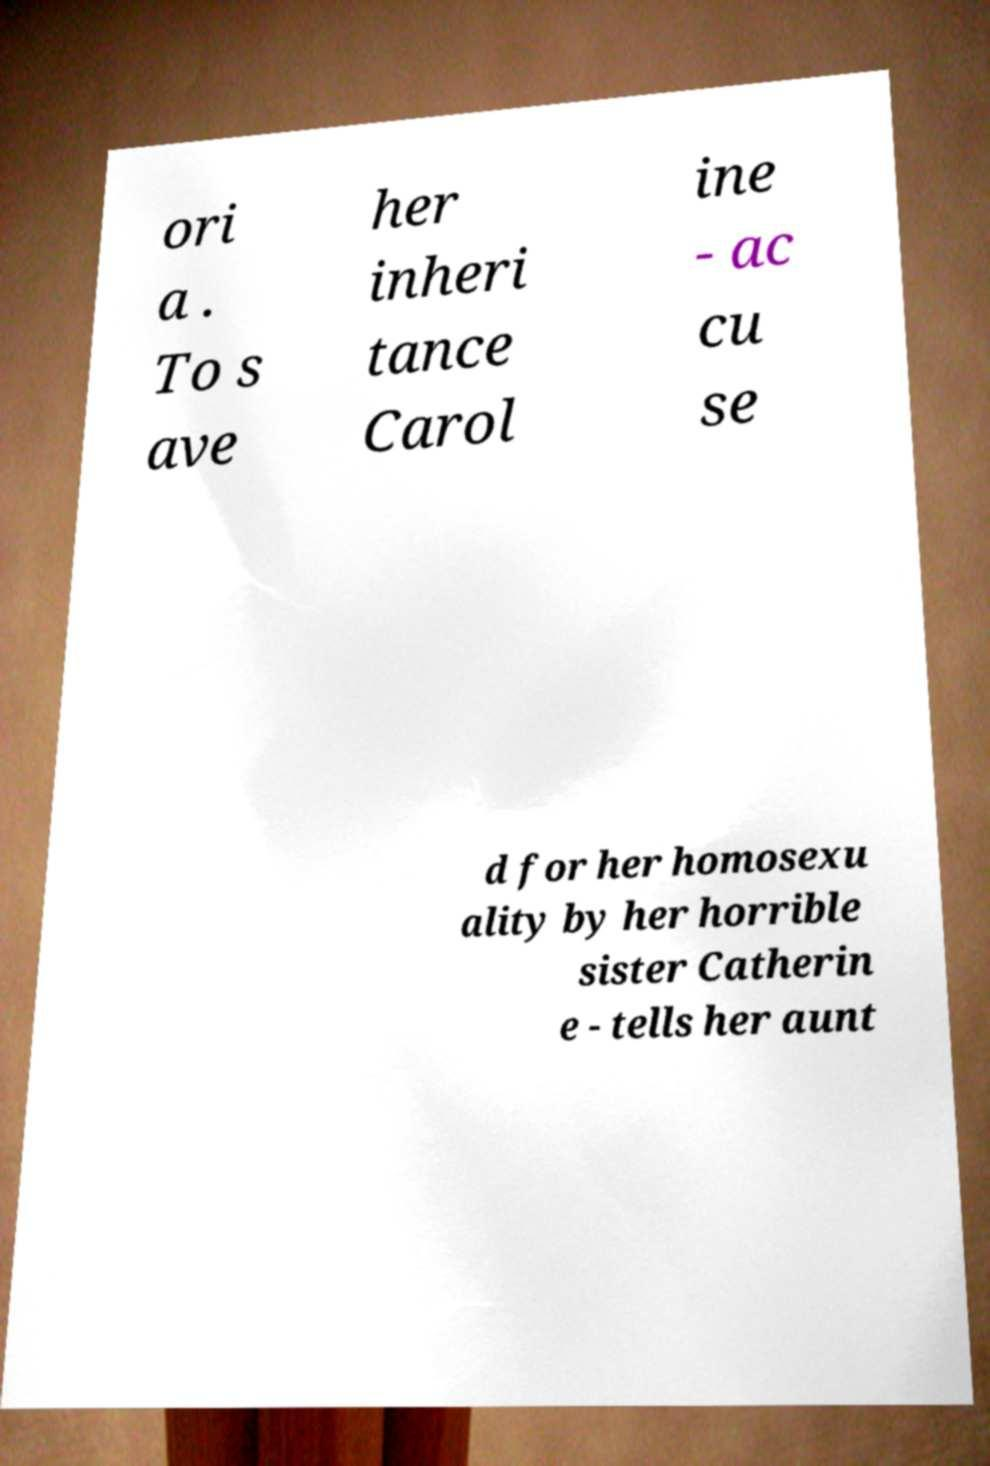Please identify and transcribe the text found in this image. ori a . To s ave her inheri tance Carol ine - ac cu se d for her homosexu ality by her horrible sister Catherin e - tells her aunt 